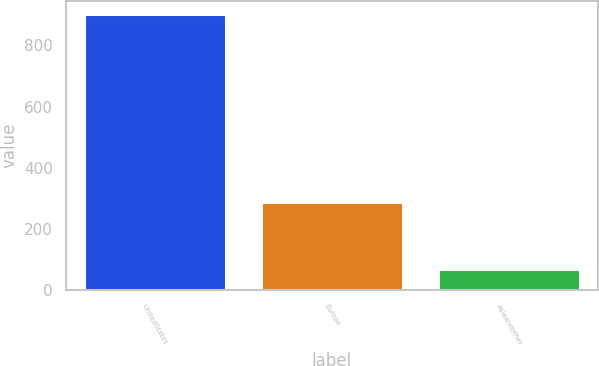Convert chart. <chart><loc_0><loc_0><loc_500><loc_500><bar_chart><fcel>UnitedStates<fcel>Europe<fcel>Asiaandother<nl><fcel>901<fcel>287<fcel>69<nl></chart> 